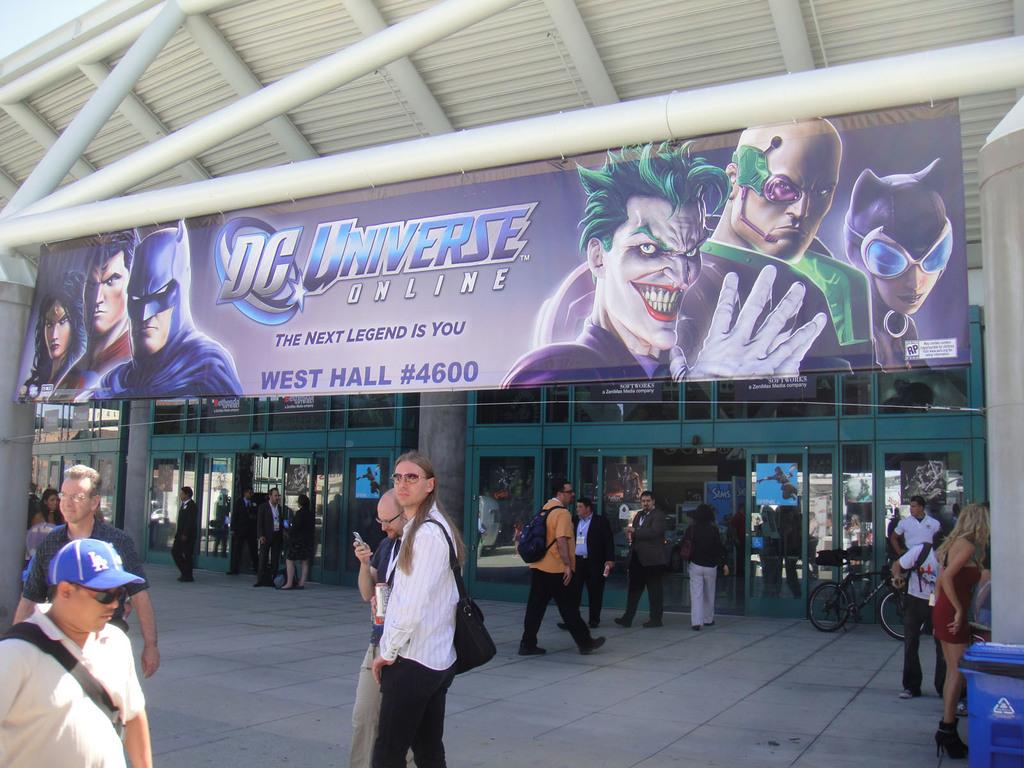Provide a one-sentence caption for the provided image. Big banner for dc universe online the next legend is you. 